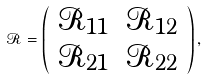Convert formula to latex. <formula><loc_0><loc_0><loc_500><loc_500>\mathcal { R } = \left ( \begin{array} { c c } \mathcal { R } _ { 1 1 } & \mathcal { R } _ { 1 2 } \\ \mathcal { R } _ { 2 1 } & \mathcal { R } _ { 2 2 } \end{array} \right ) ,</formula> 